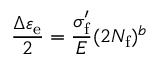<formula> <loc_0><loc_0><loc_500><loc_500>{ \frac { \Delta \varepsilon _ { e } } { 2 } } = { \frac { \sigma _ { f } ^ { \prime } } { E } } ( 2 N _ { f } ) ^ { b }</formula> 